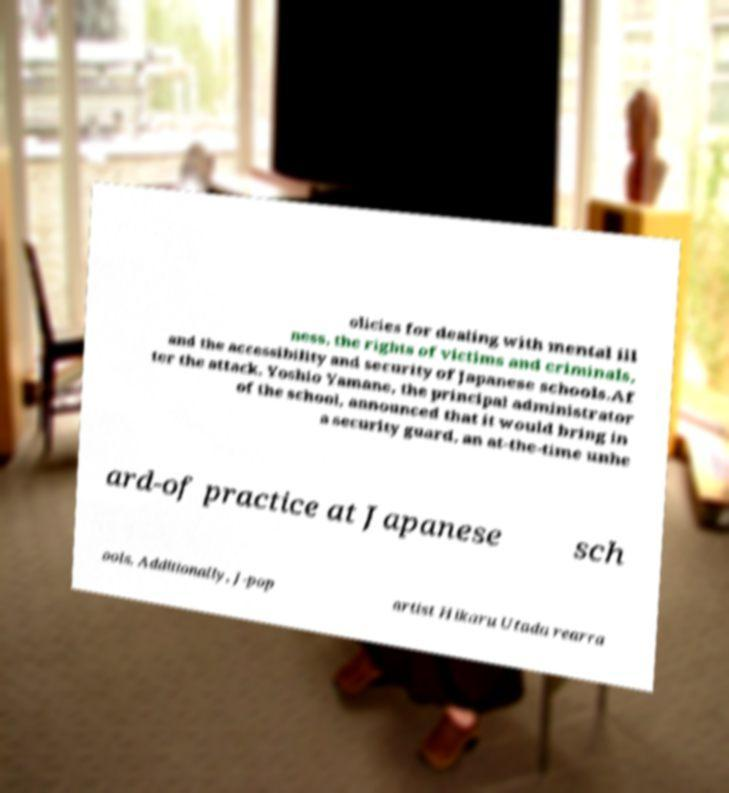For documentation purposes, I need the text within this image transcribed. Could you provide that? olicies for dealing with mental ill ness, the rights of victims and criminals, and the accessibility and security of Japanese schools.Af ter the attack, Yoshio Yamane, the principal administrator of the school, announced that it would bring in a security guard, an at-the-time unhe ard-of practice at Japanese sch ools. Additionally, J-pop artist Hikaru Utada rearra 